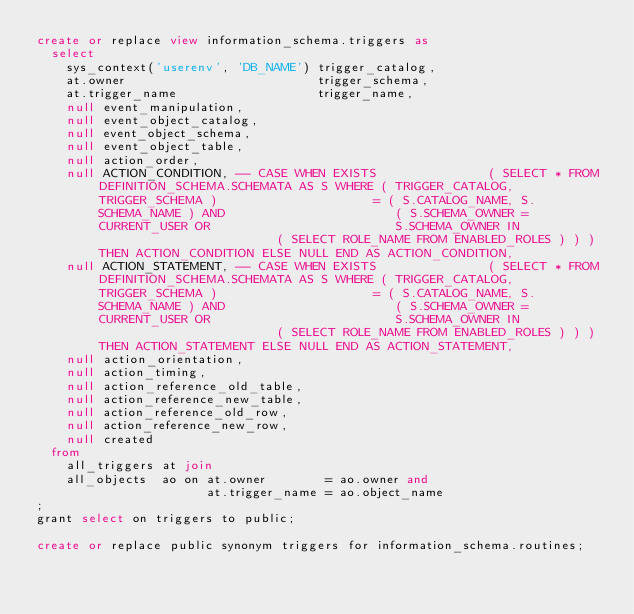<code> <loc_0><loc_0><loc_500><loc_500><_SQL_>create or replace view information_schema.triggers as
  select
    sys_context('userenv', 'DB_NAME') trigger_catalog,
    at.owner                          trigger_schema,
    at.trigger_name                   trigger_name,
    null event_manipulation,
    null event_object_catalog,
    null event_object_schema,
    null event_object_table,
    null action_order,
    null ACTION_CONDITION, -- CASE WHEN EXISTS               ( SELECT * FROM DEFINITION_SCHEMA.SCHEMATA AS S WHERE ( TRIGGER_CATALOG, TRIGGER_SCHEMA )                     = ( S.CATALOG_NAME, S.SCHEMA_NAME ) AND                       ( S.SCHEMA_OWNER = CURRENT_USER OR                         S.SCHEMA_OWNER IN                         ( SELECT ROLE_NAME FROM ENABLED_ROLES ) ) ) THEN ACTION_CONDITION ELSE NULL END AS ACTION_CONDITION,
    null ACTION_STATEMENT, -- CASE WHEN EXISTS               ( SELECT * FROM DEFINITION_SCHEMA.SCHEMATA AS S WHERE ( TRIGGER_CATALOG, TRIGGER_SCHEMA )                     = ( S.CATALOG_NAME, S.SCHEMA_NAME ) AND                       ( S.SCHEMA_OWNER = CURRENT_USER OR                         S.SCHEMA_OWNER IN                         ( SELECT ROLE_NAME FROM ENABLED_ROLES ) ) ) THEN ACTION_STATEMENT ELSE NULL END AS ACTION_STATEMENT,
    null action_orientation,
    null action_timing,
    null action_reference_old_table,
    null action_reference_new_table,
    null action_reference_old_row,
    null action_reference_new_row,
    null created
  from
    all_triggers at join
    all_objects  ao on at.owner        = ao.owner and
                       at.trigger_name = ao.object_name
;
grant select on triggers to public;

create or replace public synonym triggers for information_schema.routines;
</code> 